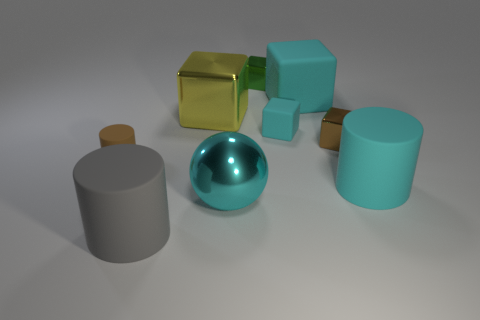Subtract all big cyan matte cubes. How many cubes are left? 4 Subtract all yellow blocks. How many blocks are left? 4 Subtract all gray cubes. Subtract all green cylinders. How many cubes are left? 5 Add 1 cyan cylinders. How many objects exist? 10 Subtract all cylinders. How many objects are left? 6 Subtract 0 purple cylinders. How many objects are left? 9 Subtract all gray objects. Subtract all cyan matte blocks. How many objects are left? 6 Add 4 yellow things. How many yellow things are left? 5 Add 9 yellow metal objects. How many yellow metal objects exist? 10 